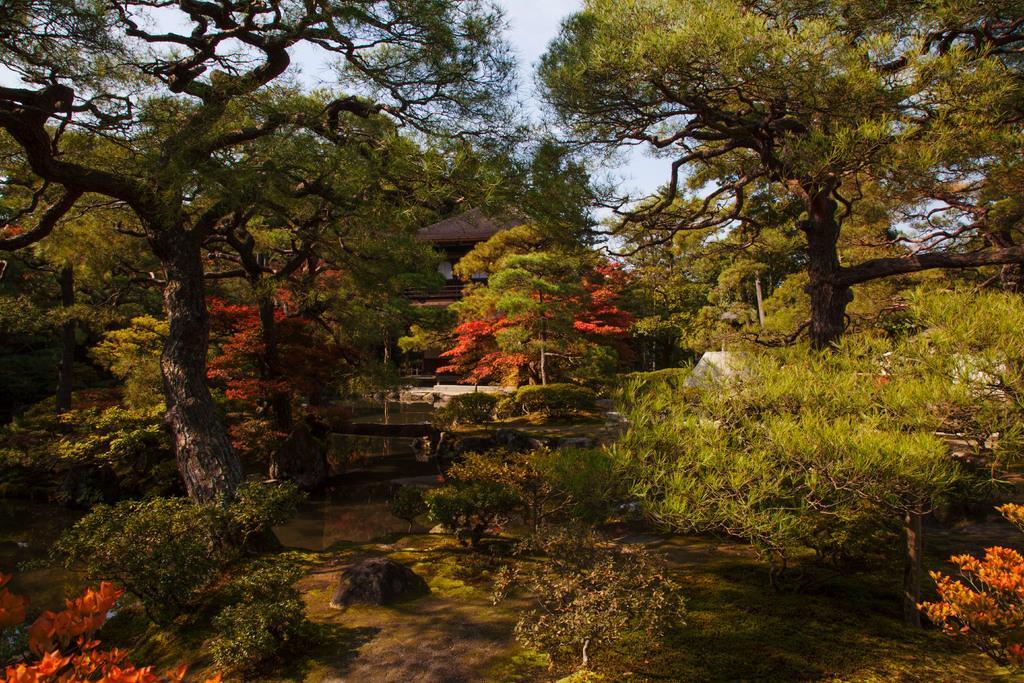Please provide a concise description of this image. In the picture I can see trees, plants, the water and a house. In the background I can see the sky. 